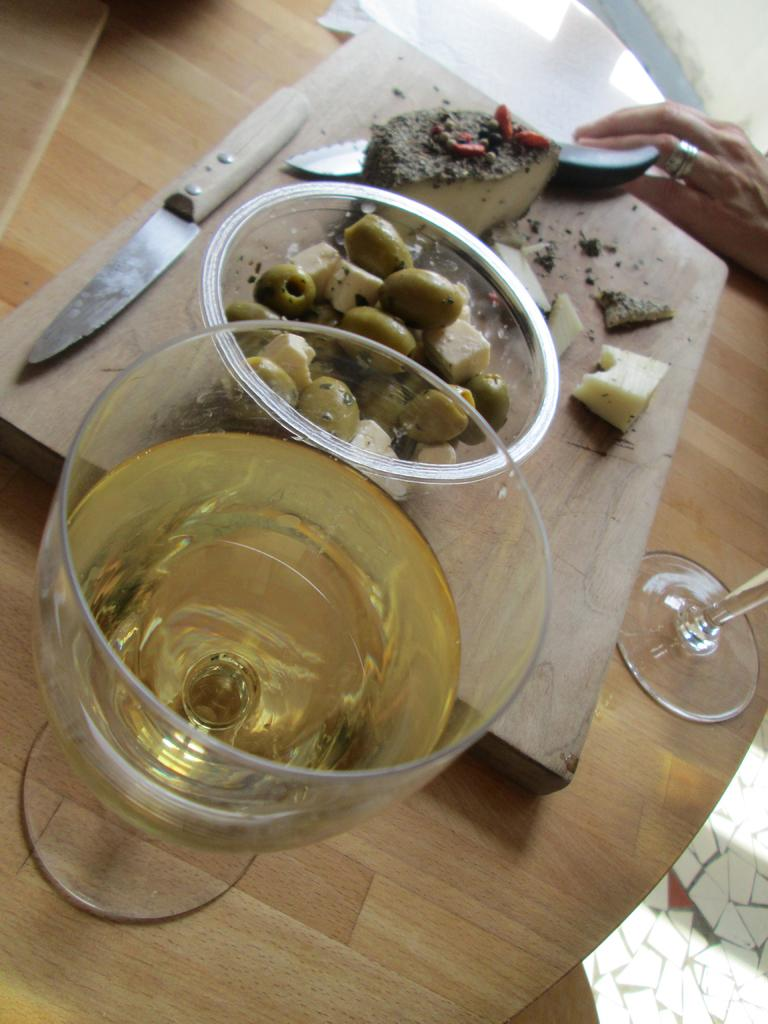What piece of furniture is present in the image? There is a table in the image. What is placed on the table? There is a chopping board on the table. What is on the chopping board? There is a knife on the chopping board, and there are food items on it. What else can be seen in the image? There is a bowl in the image, and there are food items in the bowl. What type of jail is depicted in the image? There is no jail present in the image; it features a table, chopping board, knife, bowl, and food items. What kind of experience can be gained from the potato in the image? There is no potato present in the image, so it is not possible to gain any experience from it. 